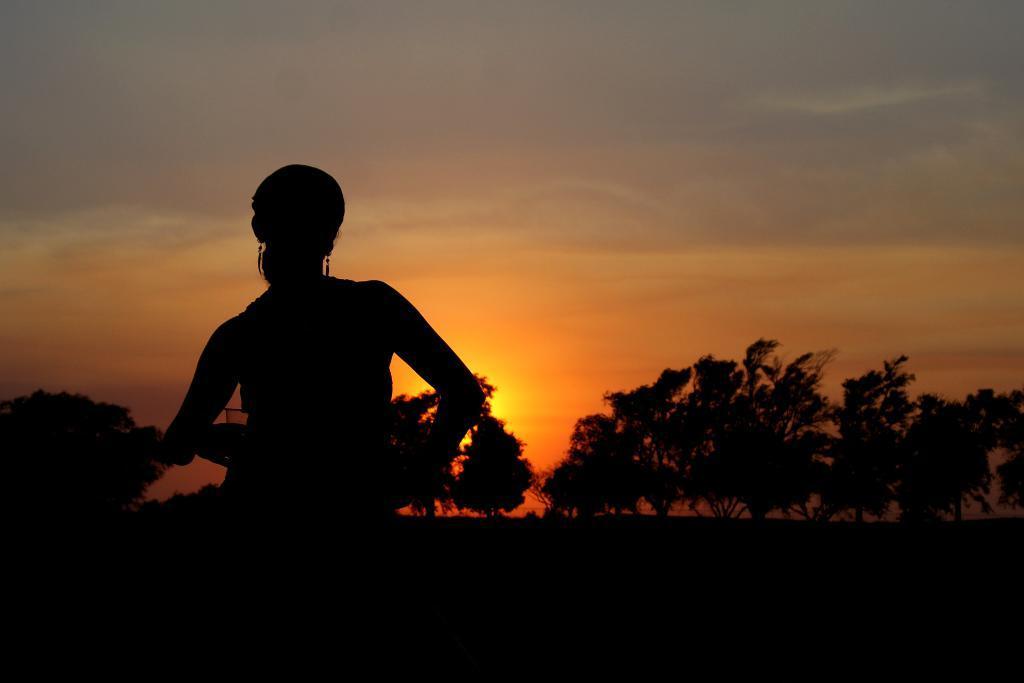How would you summarize this image in a sentence or two? In the picture we can see a woman standing in the dark and behind her we can see trees and sky with sunshine. 